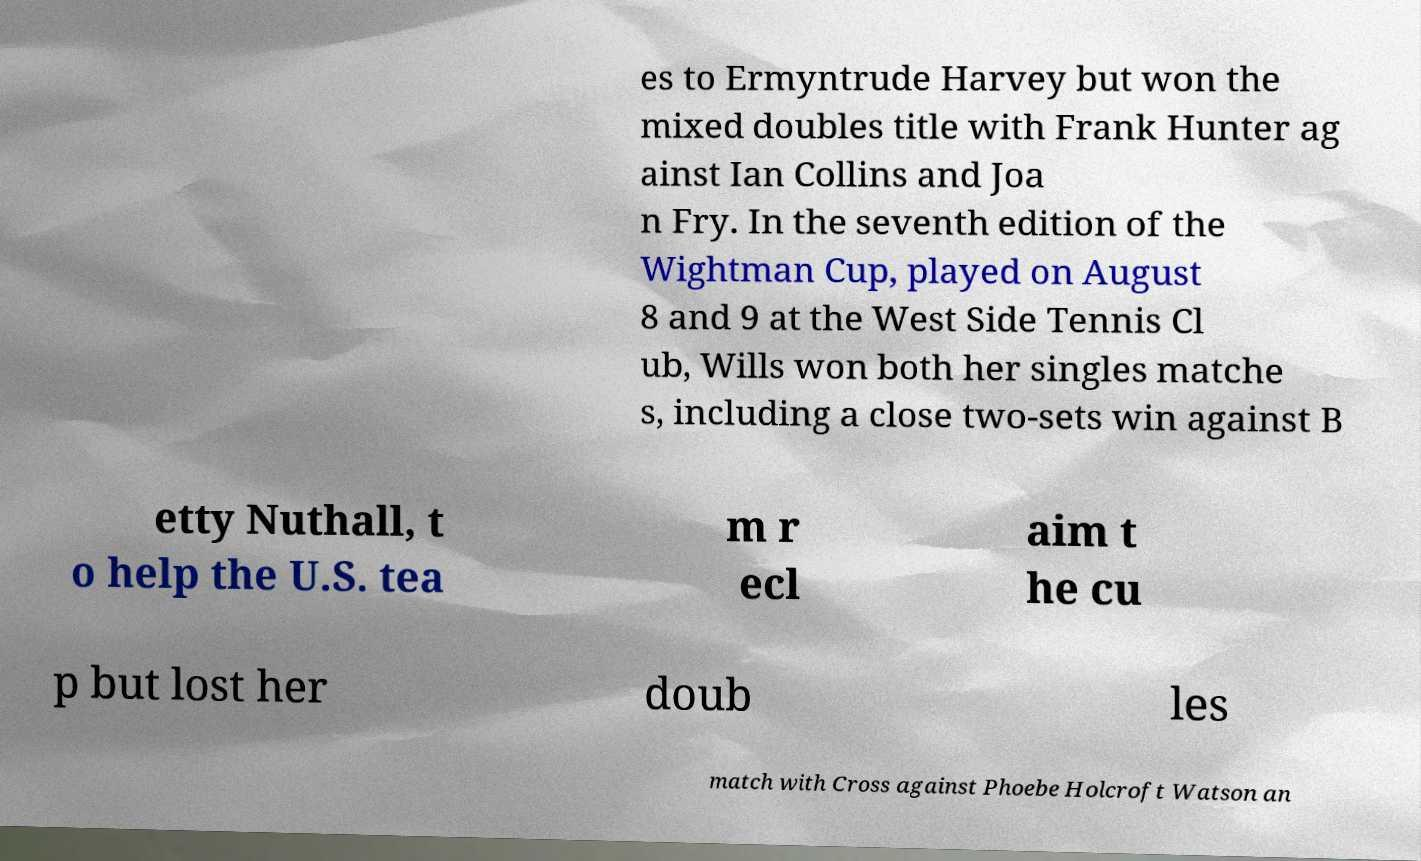Can you read and provide the text displayed in the image?This photo seems to have some interesting text. Can you extract and type it out for me? es to Ermyntrude Harvey but won the mixed doubles title with Frank Hunter ag ainst Ian Collins and Joa n Fry. In the seventh edition of the Wightman Cup, played on August 8 and 9 at the West Side Tennis Cl ub, Wills won both her singles matche s, including a close two-sets win against B etty Nuthall, t o help the U.S. tea m r ecl aim t he cu p but lost her doub les match with Cross against Phoebe Holcroft Watson an 